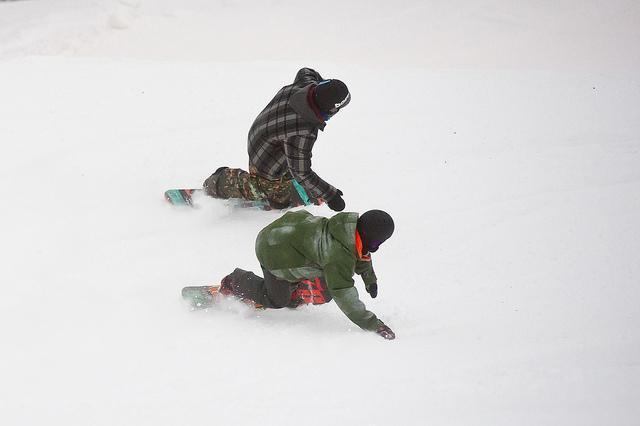How many people can you see?
Give a very brief answer. 2. 